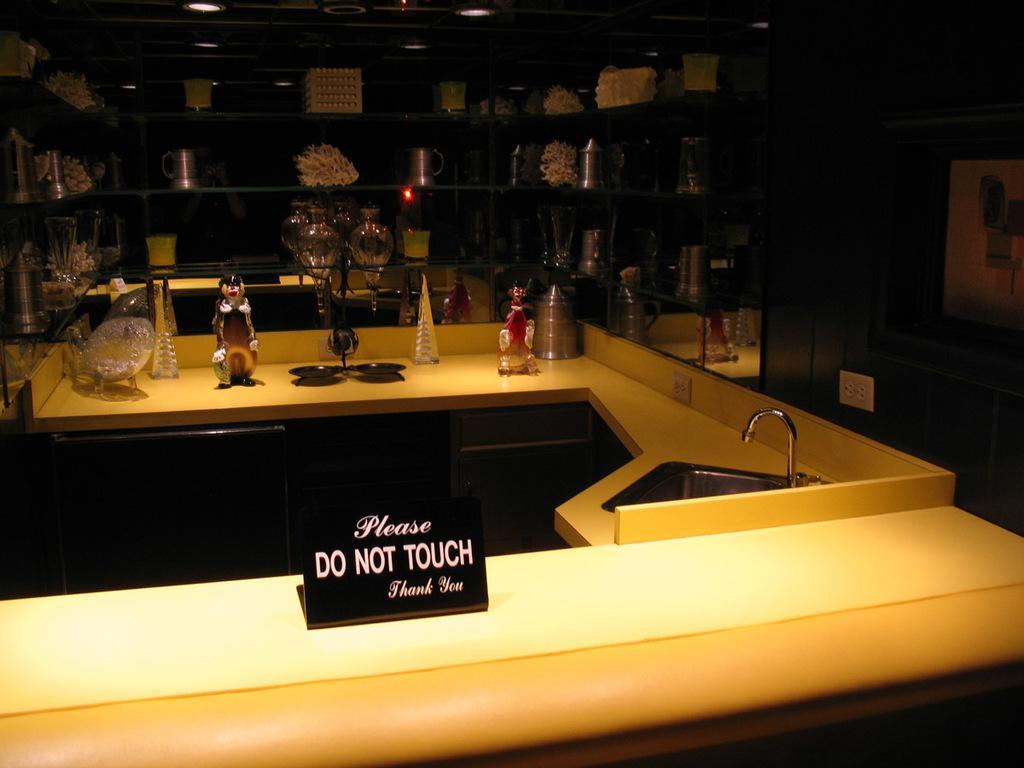In one or two sentences, can you explain what this image depicts? In the image we can see this is a basin, water tap, a toy, shelf on the shelf there are many other things, this is a board on which it is written please do not touch thank you. 